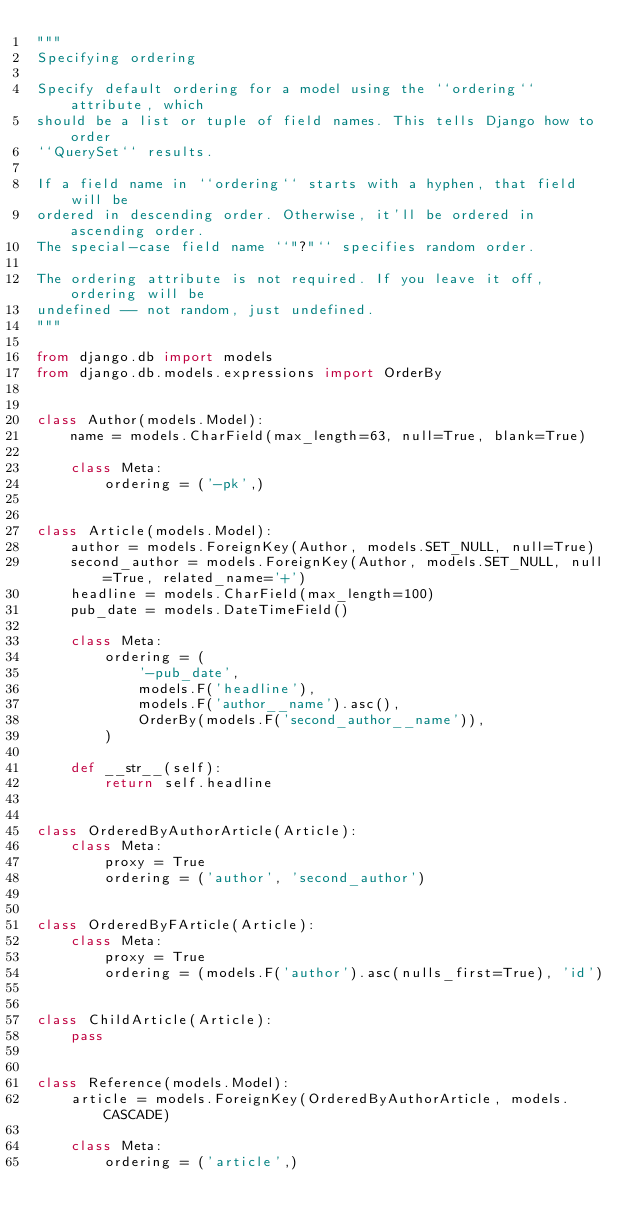<code> <loc_0><loc_0><loc_500><loc_500><_Python_>"""
Specifying ordering

Specify default ordering for a model using the ``ordering`` attribute, which
should be a list or tuple of field names. This tells Django how to order
``QuerySet`` results.

If a field name in ``ordering`` starts with a hyphen, that field will be
ordered in descending order. Otherwise, it'll be ordered in ascending order.
The special-case field name ``"?"`` specifies random order.

The ordering attribute is not required. If you leave it off, ordering will be
undefined -- not random, just undefined.
"""

from django.db import models
from django.db.models.expressions import OrderBy


class Author(models.Model):
    name = models.CharField(max_length=63, null=True, blank=True)

    class Meta:
        ordering = ('-pk',)


class Article(models.Model):
    author = models.ForeignKey(Author, models.SET_NULL, null=True)
    second_author = models.ForeignKey(Author, models.SET_NULL, null=True, related_name='+')
    headline = models.CharField(max_length=100)
    pub_date = models.DateTimeField()

    class Meta:
        ordering = (
            '-pub_date',
            models.F('headline'),
            models.F('author__name').asc(),
            OrderBy(models.F('second_author__name')),
        )

    def __str__(self):
        return self.headline


class OrderedByAuthorArticle(Article):
    class Meta:
        proxy = True
        ordering = ('author', 'second_author')


class OrderedByFArticle(Article):
    class Meta:
        proxy = True
        ordering = (models.F('author').asc(nulls_first=True), 'id')


class ChildArticle(Article):
    pass


class Reference(models.Model):
    article = models.ForeignKey(OrderedByAuthorArticle, models.CASCADE)

    class Meta:
        ordering = ('article',)
</code> 